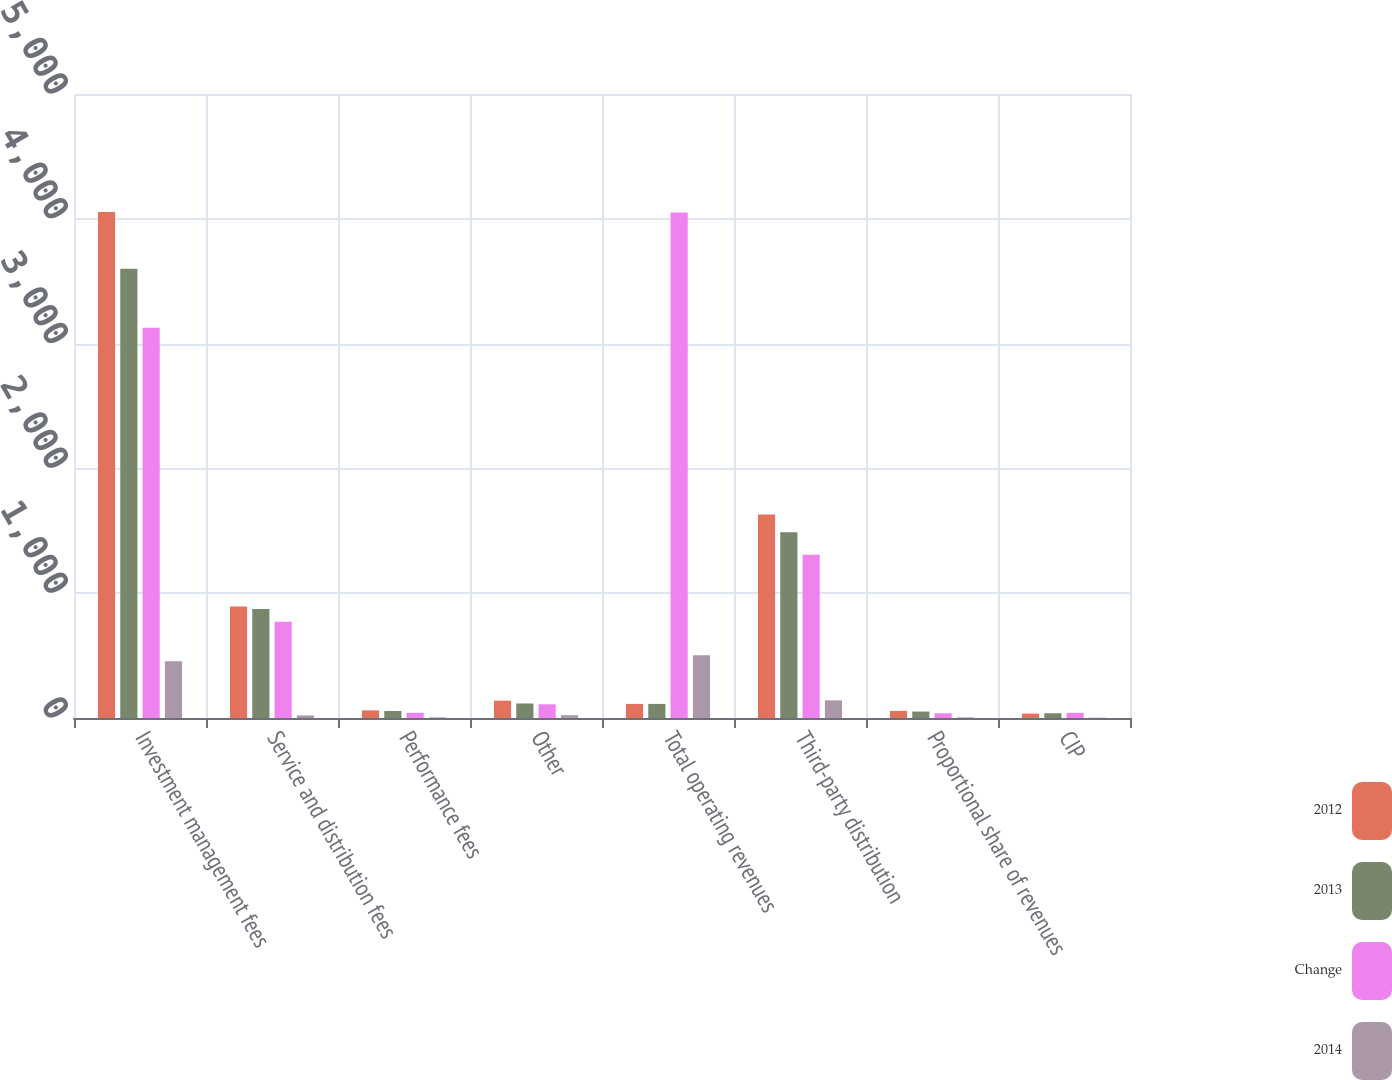<chart> <loc_0><loc_0><loc_500><loc_500><stacked_bar_chart><ecel><fcel>Investment management fees<fcel>Service and distribution fees<fcel>Performance fees<fcel>Other<fcel>Total operating revenues<fcel>Third-party distribution<fcel>Proportional share of revenues<fcel>CIP<nl><fcel>2012<fcel>4054.1<fcel>893.1<fcel>61.1<fcel>138.8<fcel>112.95<fcel>1630.7<fcel>56.7<fcel>35.2<nl><fcel>2013<fcel>3599.6<fcel>872.8<fcel>55.9<fcel>116.3<fcel>112.95<fcel>1489.2<fcel>51.7<fcel>37.9<nl><fcel>Change<fcel>3127.8<fcel>771.6<fcel>41.4<fcel>109.6<fcel>4050.4<fcel>1308.2<fcel>37.5<fcel>41<nl><fcel>2014<fcel>454.5<fcel>20.3<fcel>5.2<fcel>22.5<fcel>502.5<fcel>141.5<fcel>5<fcel>2.7<nl></chart> 